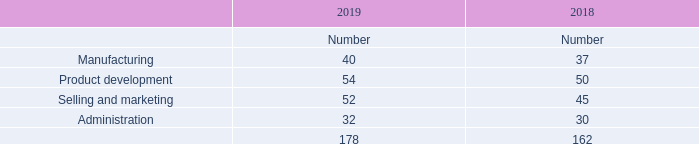2. Employees
Please refer to the Report on Directors’ remuneration on pages 77 to 101 and note 38 of Notes to the consolidated financial statements on page 161 for disclosures relating to the emoluments, share incentives and long-term incentive interests and pensions of the Directors.
The average number of people employed by the Company during the year was:
What should be referred to for disclosures relating to the emoluments, share incentives and long-term incentive interests and pensions of the Directors? Refer to the report on directors’ remuneration on pages 77 to 101 and note 38 of notes to the consolidated financial statements on page 161. What was the average number of people employed by the Company in 2019? 178. What are the different departments for which the average number of people were employed by the Company during the year was recorded? Manufacturing, product development, selling and marketing, administration. In which year was the number of employees in Selling and marketing higher? 52>45
Answer: 2019. What was the change in the average number of people employed by the company in 2019? 178-162
Answer: 16. What was the percentage change in the average number of people employed by the company in 2019?
Answer scale should be: percent. (178-162)/162
Answer: 9.88. 